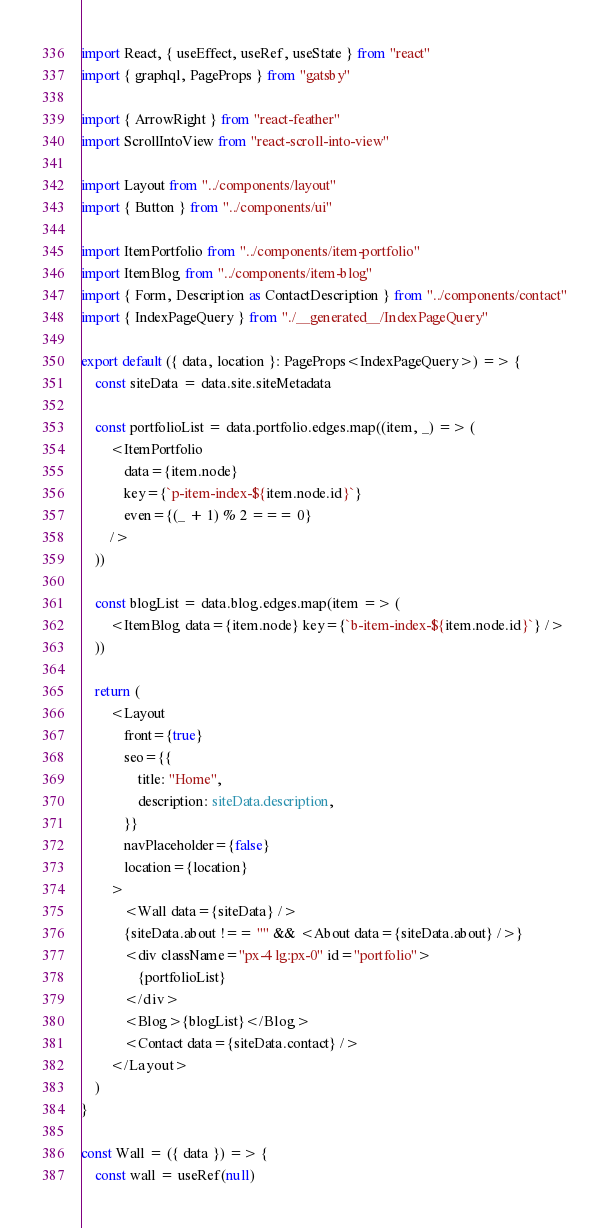Convert code to text. <code><loc_0><loc_0><loc_500><loc_500><_TypeScript_>import React, { useEffect, useRef, useState } from "react"
import { graphql, PageProps } from "gatsby"

import { ArrowRight } from "react-feather"
import ScrollIntoView from "react-scroll-into-view"

import Layout from "../components/layout"
import { Button } from "../components/ui"

import ItemPortfolio from "../components/item-portfolio"
import ItemBlog from "../components/item-blog"
import { Form, Description as ContactDescription } from "../components/contact"
import { IndexPageQuery } from "./__generated__/IndexPageQuery"

export default ({ data, location }: PageProps<IndexPageQuery>) => {
    const siteData = data.site.siteMetadata

    const portfolioList = data.portfolio.edges.map((item, _) => (
        <ItemPortfolio
            data={item.node}
            key={`p-item-index-${item.node.id}`}
            even={(_ + 1) % 2 === 0}
        />
    ))

    const blogList = data.blog.edges.map(item => (
        <ItemBlog data={item.node} key={`b-item-index-${item.node.id}`} />
    ))

    return (
        <Layout
            front={true}
            seo={{
                title: "Home",
                description: siteData.description,
            }}
            navPlaceholder={false}
            location={location}
        >
            <Wall data={siteData} />
            {siteData.about !== "" && <About data={siteData.about} />}
            <div className="px-4 lg:px-0" id="portfolio">
                {portfolioList}
            </div>
            <Blog>{blogList}</Blog>
            <Contact data={siteData.contact} />
        </Layout>
    )
}

const Wall = ({ data }) => {
    const wall = useRef(null)
</code> 